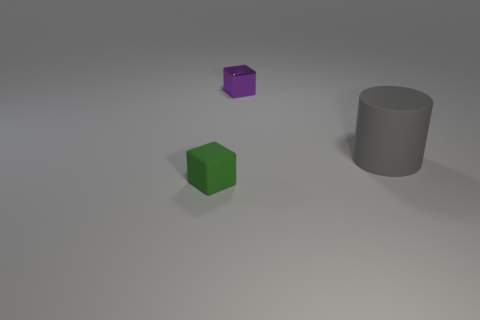Are there more large gray cylinders behind the gray matte object than cubes behind the green rubber thing?
Provide a short and direct response. No. There is a tiny cube that is right of the small rubber block; how many green cubes are behind it?
Give a very brief answer. 0. Is the shape of the object to the left of the small purple thing the same as  the purple thing?
Your answer should be very brief. Yes. What is the material of the small green object that is the same shape as the purple object?
Ensure brevity in your answer.  Rubber. How many other gray rubber cylinders have the same size as the matte cylinder?
Your answer should be compact. 0. There is a thing that is both to the right of the small green thing and on the left side of the big rubber cylinder; what is its color?
Give a very brief answer. Purple. Are there fewer tiny objects than big cyan shiny things?
Ensure brevity in your answer.  No. Does the small shiny thing have the same color as the small object in front of the gray rubber cylinder?
Offer a very short reply. No. Is the number of big gray matte cylinders behind the tiny green matte thing the same as the number of small blocks on the right side of the tiny metallic block?
Provide a short and direct response. No. How many tiny purple objects are the same shape as the green thing?
Offer a terse response. 1. 